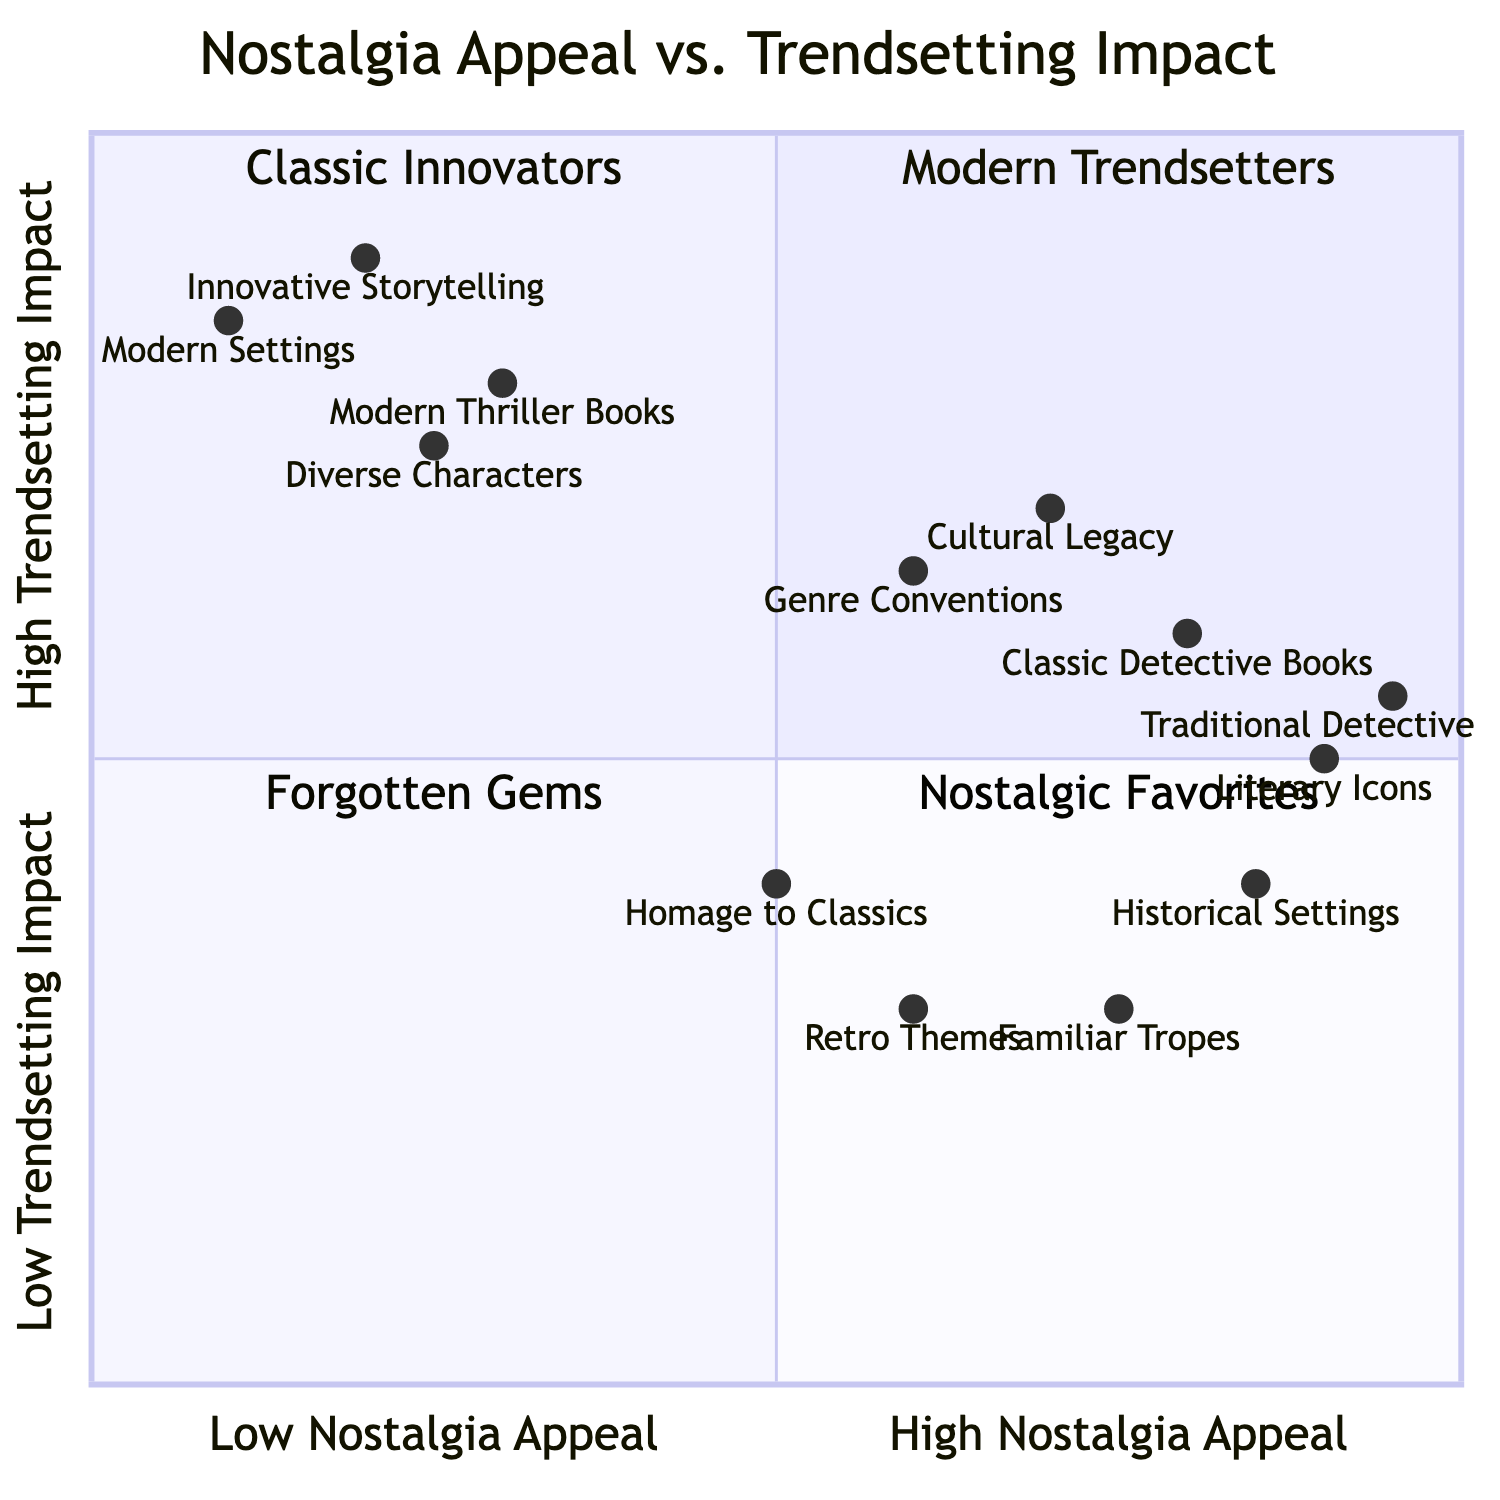What is the Nostalgia Appeal score for Classic Detective Books? According to the diagram, Classic Detective Books have a Nostalgia Appeal score of 0.8.
Answer: 0.8 What is the Trendsetting Impact score for Modern Thriller Books? The diagram shows that Modern Thriller Books have a Trendsetting Impact score of 0.8.
Answer: 0.8 Which quadrant does Literary Icons fall into? The score for Literary Icons is [0.9, 0.5]. Since its Nostalgia Appeal is high and Trendsetting Impact is moderate, it fits in quadrant 4, Nostalgic Favorites.
Answer: Nostalgic Favorites How many elements have a high Trendsetting Impact (above 0.7)? Looking at the scores, Cultural Legacy (0.7), Innovative Storytelling (0.9), Modern Settings (0.85), and Diverse Characters (0.75) all have scores above 0.7, totaling four elements.
Answer: 4 What is the positional relationship between Modern Settings and Traditional Detective Archetype? Modern Settings has a lower Nostalgia Appeal score (0.1) compared to Traditional Detective Archetype (0.95), but a similar Trendsetting Impact score (0.85 vs 0.55), indicating a shift from nostalgia to innovation for Modern Settings.
Answer: Nostalgia vs Innovation What is the common theme among Classic Detective Books? The common theme is high Nostalgia Appeal, demonstrated by their high scores in elements like Literary Icons and Traditional Detective Archetypes, which emphasize strong cultural nostalgia.
Answer: High Nostalgia Appeal How does the Nostalgia Appeal of Modern Thriller Books compare to Classic Detective Books? Modern Thriller Books have a lower Nostalgia Appeal score of 0.3 compared to Classic Detective Books' score of 0.8, indicating they are less nostalgic.
Answer: Lower Nostalgia Appeal Which element has the highest Trendsetting Impact? The element with the highest Trendsetting Impact score is Innovative Storytelling, with a score of 0.9.
Answer: 0.9 In which quadrant would you categorize Modern Thriller Books? Given the scores [0.3, 0.8], Modern Thriller Books fall into quadrant 1, labeled Modern Trendsetters, due to their lower Nostalgia Appeal and higher Trendsetting Impact.
Answer: Modern Trendsetters 